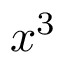<formula> <loc_0><loc_0><loc_500><loc_500>x ^ { 3 }</formula> 